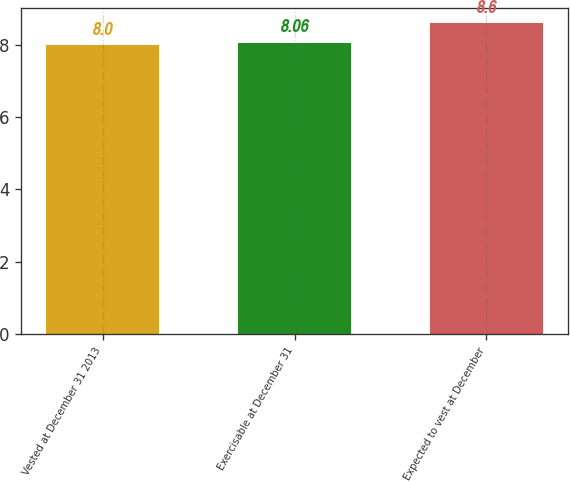<chart> <loc_0><loc_0><loc_500><loc_500><bar_chart><fcel>Vested at December 31 2013<fcel>Exercisable at December 31<fcel>Expected to vest at December<nl><fcel>8<fcel>8.06<fcel>8.6<nl></chart> 